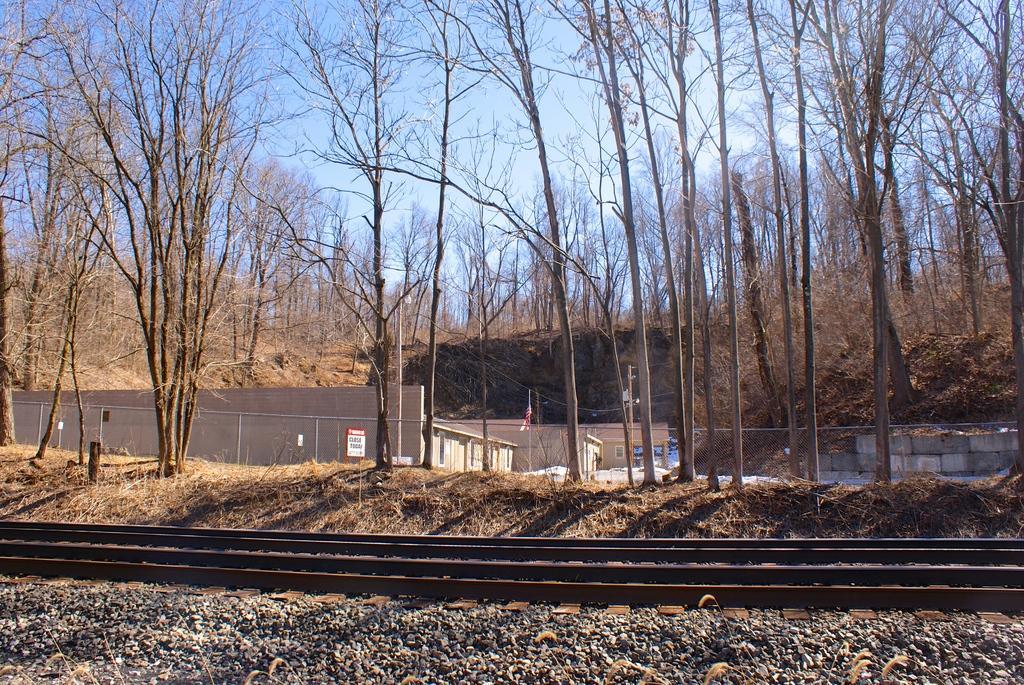How would you summarize this image in a sentence or two? In this picture we can see stones, railway tracks, fence, buildings, trees and in the background we can see the sky. 